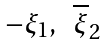Convert formula to latex. <formula><loc_0><loc_0><loc_500><loc_500>\begin{matrix} - \xi _ { 1 } , & \overline { \xi } _ { 2 } \end{matrix}</formula> 